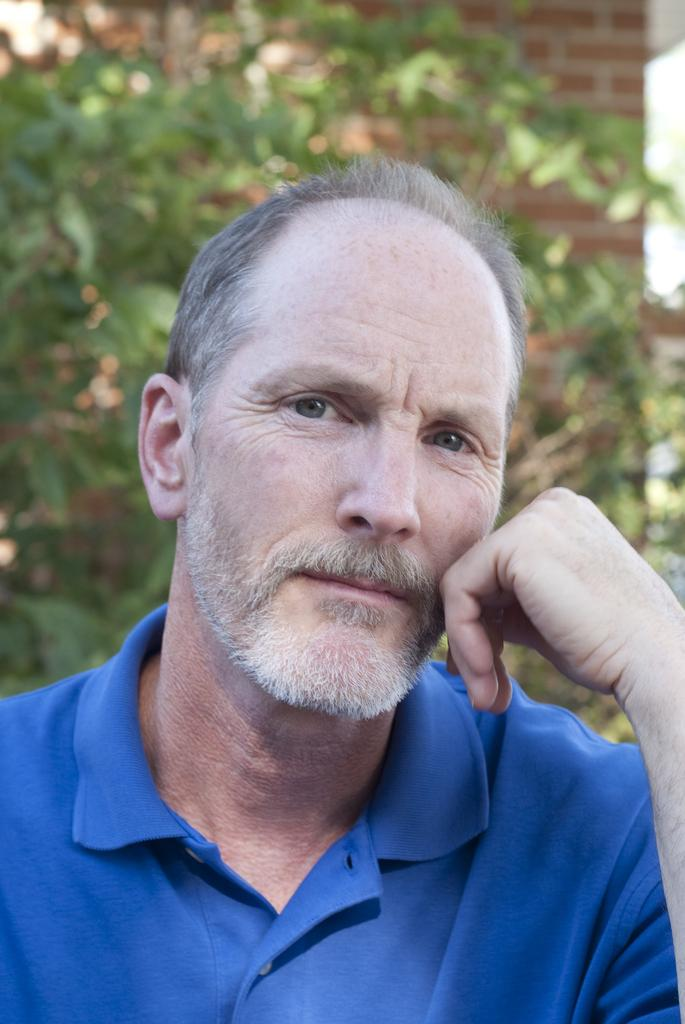What is the main subject of the image? There is a person in the image. What can be seen in the background of the image? There are trees and a wall in the background of the image. What type of wound can be seen on the person's arm in the image? There is no wound visible on the person's arm in the image. Is the person riding a bike in the image? There is no bike present in the image. 